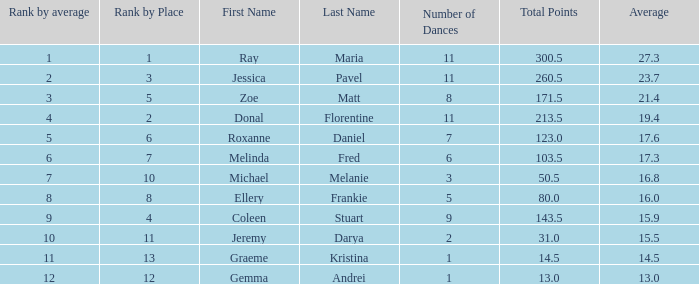If the total points is 50.5, what is the total number of dances? 1.0. 